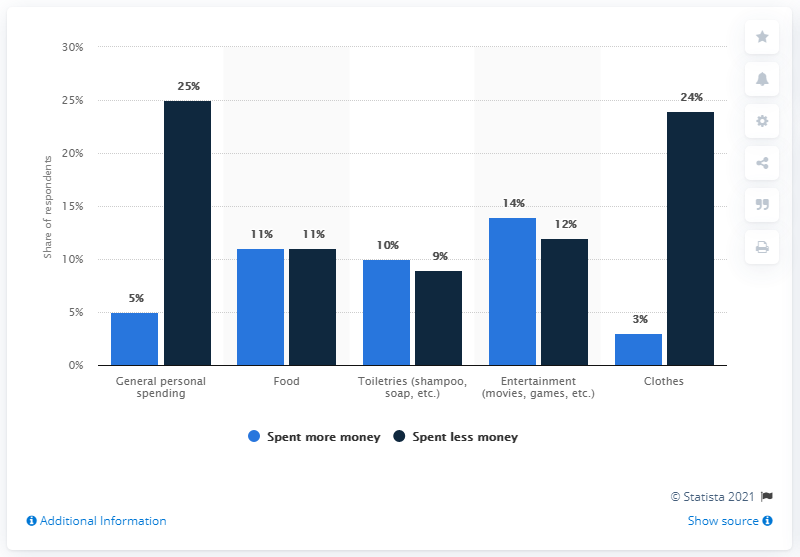Point out several critical features in this image. The category that has the highest difference between spending more money and spending less money is clothes. The color navy blue has the highest value. 